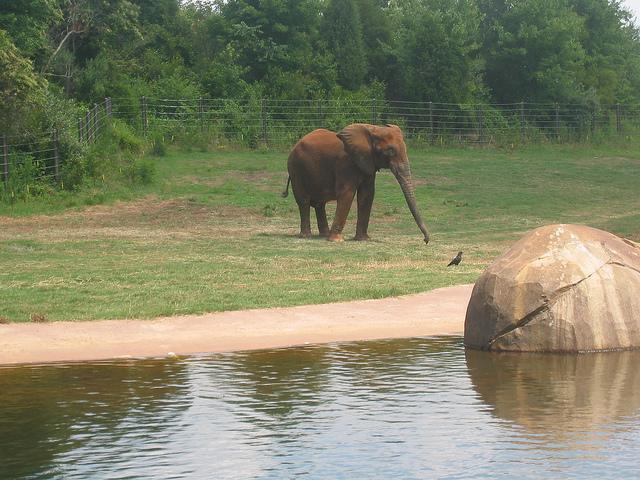Is the Boulder in the water man-made?
Quick response, please. Yes. Is this elephant in the wild?
Give a very brief answer. No. What color is the elephant?
Be succinct. Brown. 